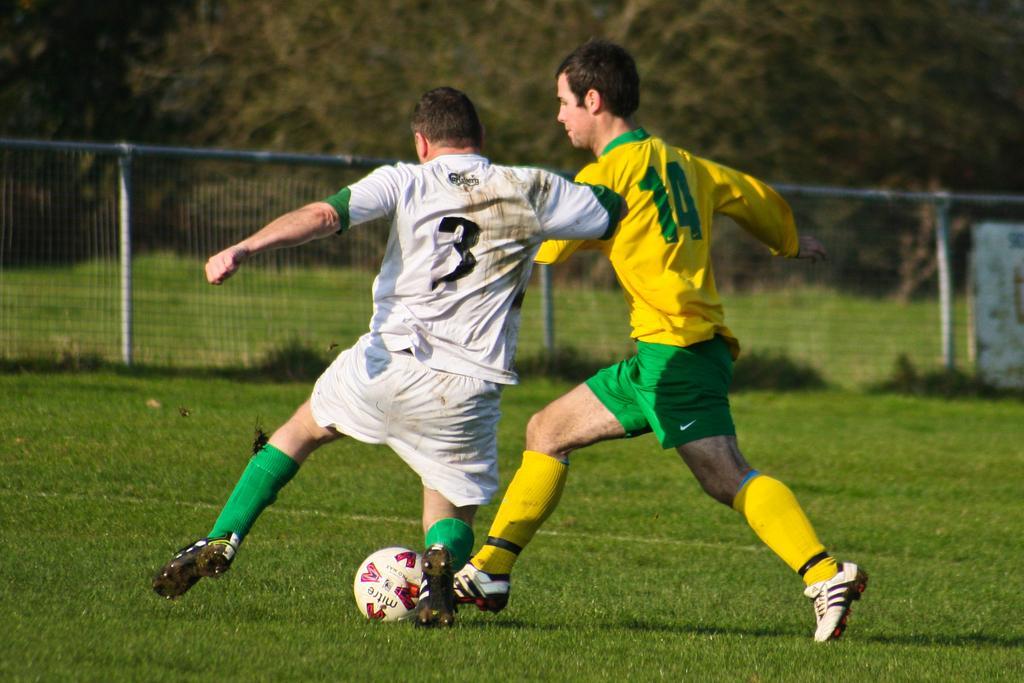Can you describe this image briefly? In this picture we can see two persons are playing in the ground. This is ball. On the background there is a fence and these are the trees. And this is grass. 